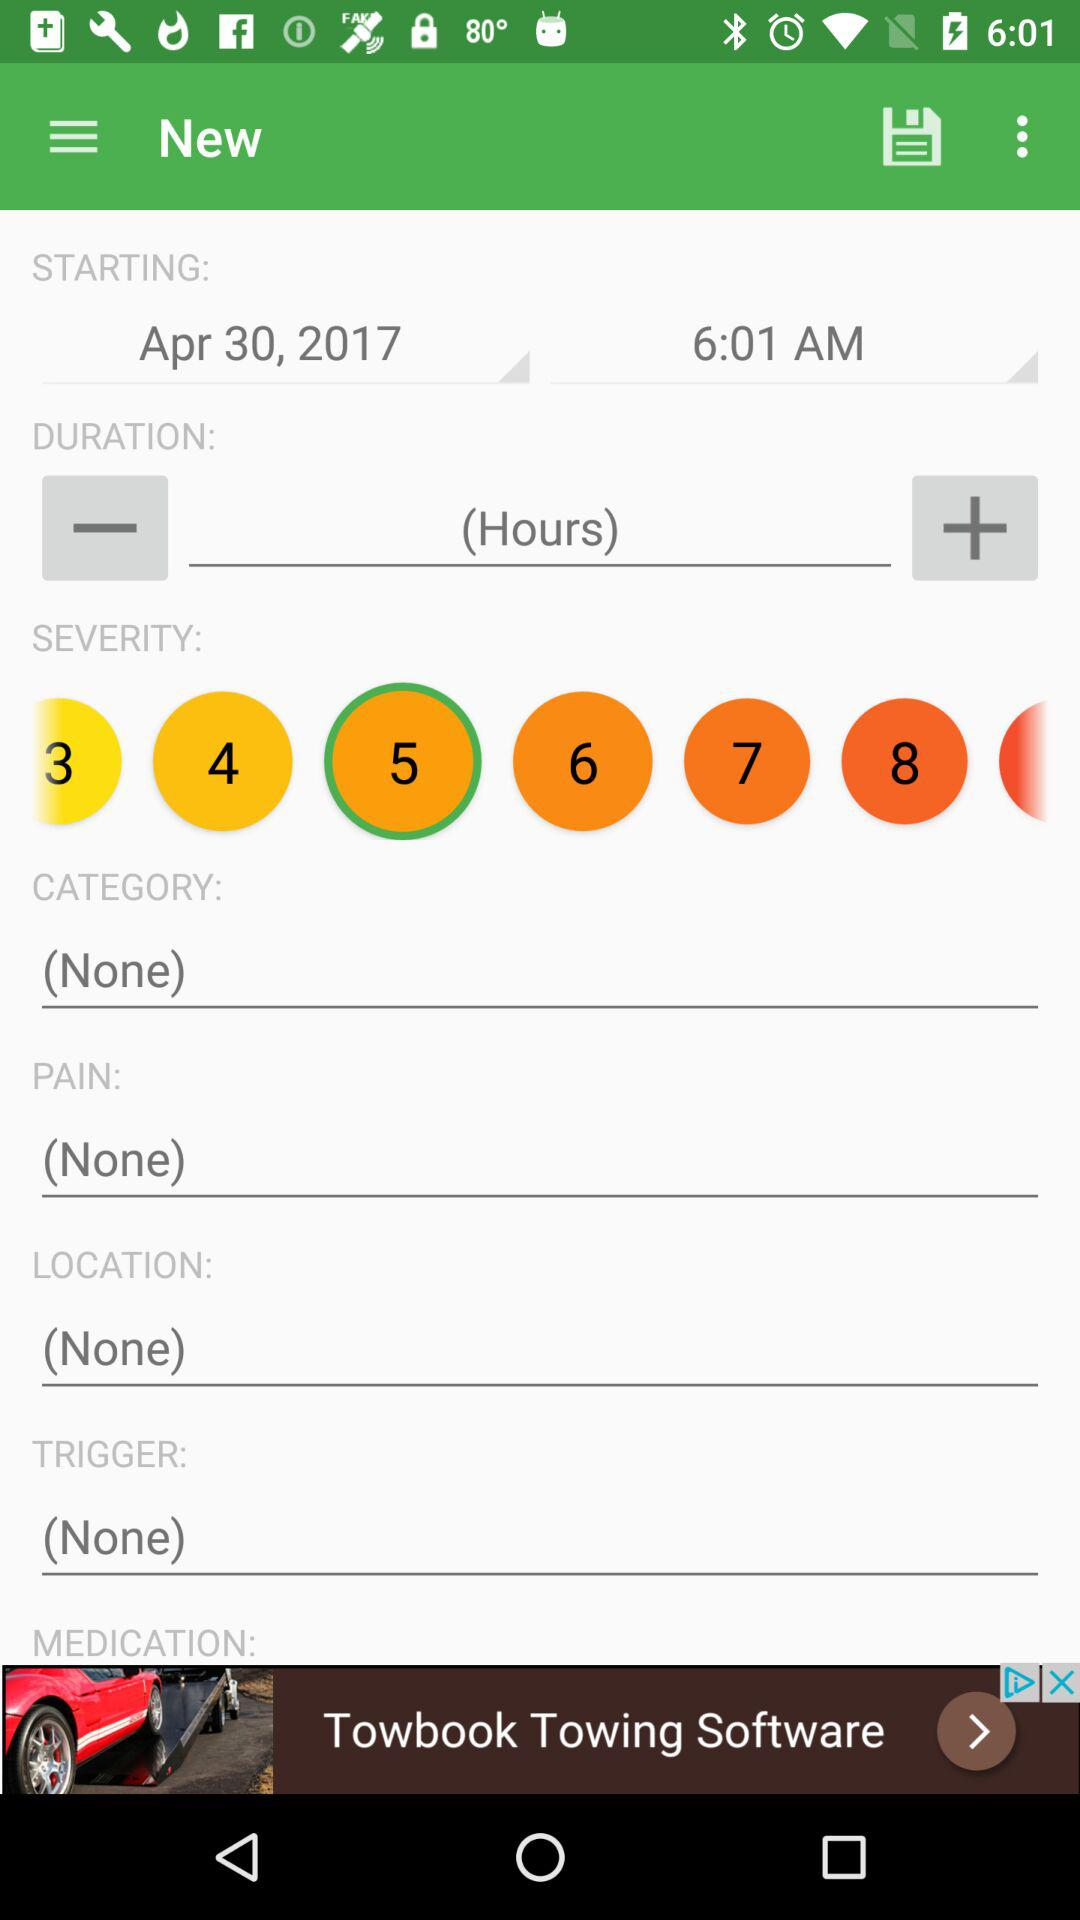What is the shown start date? The shown start date is April 30, 2017. 